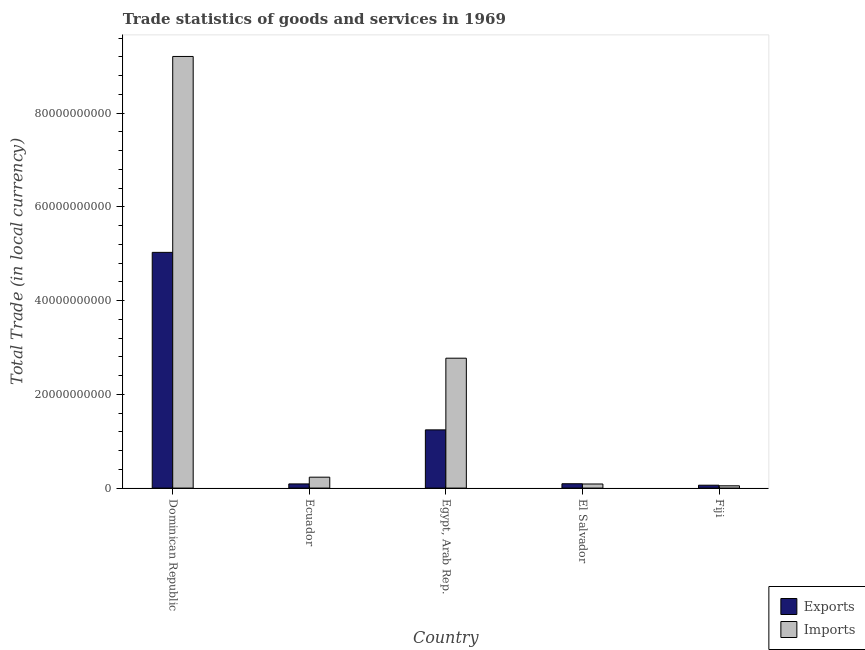How many bars are there on the 2nd tick from the left?
Provide a succinct answer. 2. How many bars are there on the 5th tick from the right?
Ensure brevity in your answer.  2. What is the label of the 1st group of bars from the left?
Make the answer very short. Dominican Republic. What is the imports of goods and services in El Salvador?
Your answer should be very brief. 8.73e+08. Across all countries, what is the maximum imports of goods and services?
Your answer should be compact. 9.21e+1. Across all countries, what is the minimum export of goods and services?
Provide a short and direct response. 6.16e+08. In which country was the imports of goods and services maximum?
Keep it short and to the point. Dominican Republic. In which country was the imports of goods and services minimum?
Make the answer very short. Fiji. What is the total imports of goods and services in the graph?
Give a very brief answer. 1.23e+11. What is the difference between the export of goods and services in Ecuador and that in Fiji?
Provide a succinct answer. 2.75e+08. What is the difference between the imports of goods and services in Ecuador and the export of goods and services in Egypt, Arab Rep.?
Your response must be concise. -1.01e+1. What is the average export of goods and services per country?
Give a very brief answer. 1.30e+1. What is the difference between the export of goods and services and imports of goods and services in Dominican Republic?
Ensure brevity in your answer.  -4.18e+1. In how many countries, is the imports of goods and services greater than 60000000000 LCU?
Your response must be concise. 1. What is the ratio of the imports of goods and services in Egypt, Arab Rep. to that in El Salvador?
Provide a short and direct response. 31.73. Is the difference between the imports of goods and services in Egypt, Arab Rep. and El Salvador greater than the difference between the export of goods and services in Egypt, Arab Rep. and El Salvador?
Keep it short and to the point. Yes. What is the difference between the highest and the second highest imports of goods and services?
Provide a short and direct response. 6.44e+1. What is the difference between the highest and the lowest export of goods and services?
Offer a terse response. 4.97e+1. In how many countries, is the export of goods and services greater than the average export of goods and services taken over all countries?
Your answer should be very brief. 1. Is the sum of the export of goods and services in Dominican Republic and El Salvador greater than the maximum imports of goods and services across all countries?
Make the answer very short. No. What does the 1st bar from the left in Fiji represents?
Your response must be concise. Exports. What does the 1st bar from the right in Fiji represents?
Make the answer very short. Imports. Are the values on the major ticks of Y-axis written in scientific E-notation?
Provide a succinct answer. No. Does the graph contain any zero values?
Ensure brevity in your answer.  No. Does the graph contain grids?
Make the answer very short. No. Where does the legend appear in the graph?
Offer a very short reply. Bottom right. How many legend labels are there?
Keep it short and to the point. 2. What is the title of the graph?
Your answer should be very brief. Trade statistics of goods and services in 1969. Does "Agricultural land" appear as one of the legend labels in the graph?
Keep it short and to the point. No. What is the label or title of the Y-axis?
Your answer should be compact. Total Trade (in local currency). What is the Total Trade (in local currency) of Exports in Dominican Republic?
Ensure brevity in your answer.  5.03e+1. What is the Total Trade (in local currency) in Imports in Dominican Republic?
Give a very brief answer. 9.21e+1. What is the Total Trade (in local currency) of Exports in Ecuador?
Provide a succinct answer. 8.91e+08. What is the Total Trade (in local currency) of Imports in Ecuador?
Your answer should be very brief. 2.33e+09. What is the Total Trade (in local currency) in Exports in Egypt, Arab Rep.?
Give a very brief answer. 1.24e+1. What is the Total Trade (in local currency) in Imports in Egypt, Arab Rep.?
Your response must be concise. 2.77e+1. What is the Total Trade (in local currency) of Exports in El Salvador?
Your answer should be very brief. 9.28e+08. What is the Total Trade (in local currency) in Imports in El Salvador?
Offer a very short reply. 8.73e+08. What is the Total Trade (in local currency) in Exports in Fiji?
Provide a succinct answer. 6.16e+08. What is the Total Trade (in local currency) in Imports in Fiji?
Give a very brief answer. 4.89e+08. Across all countries, what is the maximum Total Trade (in local currency) of Exports?
Offer a terse response. 5.03e+1. Across all countries, what is the maximum Total Trade (in local currency) of Imports?
Ensure brevity in your answer.  9.21e+1. Across all countries, what is the minimum Total Trade (in local currency) of Exports?
Your response must be concise. 6.16e+08. Across all countries, what is the minimum Total Trade (in local currency) of Imports?
Keep it short and to the point. 4.89e+08. What is the total Total Trade (in local currency) in Exports in the graph?
Provide a succinct answer. 6.51e+1. What is the total Total Trade (in local currency) of Imports in the graph?
Offer a very short reply. 1.23e+11. What is the difference between the Total Trade (in local currency) in Exports in Dominican Republic and that in Ecuador?
Give a very brief answer. 4.94e+1. What is the difference between the Total Trade (in local currency) in Imports in Dominican Republic and that in Ecuador?
Keep it short and to the point. 8.98e+1. What is the difference between the Total Trade (in local currency) in Exports in Dominican Republic and that in Egypt, Arab Rep.?
Offer a very short reply. 3.79e+1. What is the difference between the Total Trade (in local currency) in Imports in Dominican Republic and that in Egypt, Arab Rep.?
Offer a very short reply. 6.44e+1. What is the difference between the Total Trade (in local currency) in Exports in Dominican Republic and that in El Salvador?
Offer a very short reply. 4.94e+1. What is the difference between the Total Trade (in local currency) of Imports in Dominican Republic and that in El Salvador?
Provide a short and direct response. 9.12e+1. What is the difference between the Total Trade (in local currency) of Exports in Dominican Republic and that in Fiji?
Provide a succinct answer. 4.97e+1. What is the difference between the Total Trade (in local currency) in Imports in Dominican Republic and that in Fiji?
Make the answer very short. 9.16e+1. What is the difference between the Total Trade (in local currency) of Exports in Ecuador and that in Egypt, Arab Rep.?
Ensure brevity in your answer.  -1.15e+1. What is the difference between the Total Trade (in local currency) in Imports in Ecuador and that in Egypt, Arab Rep.?
Your answer should be very brief. -2.54e+1. What is the difference between the Total Trade (in local currency) of Exports in Ecuador and that in El Salvador?
Provide a succinct answer. -3.66e+07. What is the difference between the Total Trade (in local currency) in Imports in Ecuador and that in El Salvador?
Your answer should be very brief. 1.46e+09. What is the difference between the Total Trade (in local currency) of Exports in Ecuador and that in Fiji?
Make the answer very short. 2.75e+08. What is the difference between the Total Trade (in local currency) in Imports in Ecuador and that in Fiji?
Make the answer very short. 1.84e+09. What is the difference between the Total Trade (in local currency) of Exports in Egypt, Arab Rep. and that in El Salvador?
Your response must be concise. 1.15e+1. What is the difference between the Total Trade (in local currency) of Imports in Egypt, Arab Rep. and that in El Salvador?
Your answer should be compact. 2.68e+1. What is the difference between the Total Trade (in local currency) of Exports in Egypt, Arab Rep. and that in Fiji?
Offer a terse response. 1.18e+1. What is the difference between the Total Trade (in local currency) in Imports in Egypt, Arab Rep. and that in Fiji?
Keep it short and to the point. 2.72e+1. What is the difference between the Total Trade (in local currency) of Exports in El Salvador and that in Fiji?
Your answer should be very brief. 3.12e+08. What is the difference between the Total Trade (in local currency) of Imports in El Salvador and that in Fiji?
Provide a short and direct response. 3.84e+08. What is the difference between the Total Trade (in local currency) in Exports in Dominican Republic and the Total Trade (in local currency) in Imports in Ecuador?
Give a very brief answer. 4.80e+1. What is the difference between the Total Trade (in local currency) in Exports in Dominican Republic and the Total Trade (in local currency) in Imports in Egypt, Arab Rep.?
Ensure brevity in your answer.  2.26e+1. What is the difference between the Total Trade (in local currency) of Exports in Dominican Republic and the Total Trade (in local currency) of Imports in El Salvador?
Make the answer very short. 4.94e+1. What is the difference between the Total Trade (in local currency) of Exports in Dominican Republic and the Total Trade (in local currency) of Imports in Fiji?
Offer a terse response. 4.98e+1. What is the difference between the Total Trade (in local currency) in Exports in Ecuador and the Total Trade (in local currency) in Imports in Egypt, Arab Rep.?
Provide a short and direct response. -2.68e+1. What is the difference between the Total Trade (in local currency) of Exports in Ecuador and the Total Trade (in local currency) of Imports in El Salvador?
Offer a terse response. 1.78e+07. What is the difference between the Total Trade (in local currency) of Exports in Ecuador and the Total Trade (in local currency) of Imports in Fiji?
Keep it short and to the point. 4.02e+08. What is the difference between the Total Trade (in local currency) in Exports in Egypt, Arab Rep. and the Total Trade (in local currency) in Imports in El Salvador?
Offer a terse response. 1.15e+1. What is the difference between the Total Trade (in local currency) of Exports in Egypt, Arab Rep. and the Total Trade (in local currency) of Imports in Fiji?
Keep it short and to the point. 1.19e+1. What is the difference between the Total Trade (in local currency) of Exports in El Salvador and the Total Trade (in local currency) of Imports in Fiji?
Ensure brevity in your answer.  4.39e+08. What is the average Total Trade (in local currency) in Exports per country?
Your answer should be very brief. 1.30e+1. What is the average Total Trade (in local currency) of Imports per country?
Your answer should be very brief. 2.47e+1. What is the difference between the Total Trade (in local currency) of Exports and Total Trade (in local currency) of Imports in Dominican Republic?
Your response must be concise. -4.18e+1. What is the difference between the Total Trade (in local currency) in Exports and Total Trade (in local currency) in Imports in Ecuador?
Offer a very short reply. -1.44e+09. What is the difference between the Total Trade (in local currency) in Exports and Total Trade (in local currency) in Imports in Egypt, Arab Rep.?
Provide a succinct answer. -1.53e+1. What is the difference between the Total Trade (in local currency) in Exports and Total Trade (in local currency) in Imports in El Salvador?
Keep it short and to the point. 5.44e+07. What is the difference between the Total Trade (in local currency) in Exports and Total Trade (in local currency) in Imports in Fiji?
Provide a short and direct response. 1.27e+08. What is the ratio of the Total Trade (in local currency) of Exports in Dominican Republic to that in Ecuador?
Provide a succinct answer. 56.43. What is the ratio of the Total Trade (in local currency) in Imports in Dominican Republic to that in Ecuador?
Ensure brevity in your answer.  39.55. What is the ratio of the Total Trade (in local currency) of Exports in Dominican Republic to that in Egypt, Arab Rep.?
Your answer should be compact. 4.05. What is the ratio of the Total Trade (in local currency) of Imports in Dominican Republic to that in Egypt, Arab Rep.?
Ensure brevity in your answer.  3.32. What is the ratio of the Total Trade (in local currency) of Exports in Dominican Republic to that in El Salvador?
Offer a very short reply. 54.2. What is the ratio of the Total Trade (in local currency) in Imports in Dominican Republic to that in El Salvador?
Ensure brevity in your answer.  105.44. What is the ratio of the Total Trade (in local currency) of Exports in Dominican Republic to that in Fiji?
Your answer should be compact. 81.63. What is the ratio of the Total Trade (in local currency) of Imports in Dominican Republic to that in Fiji?
Your answer should be very brief. 188.21. What is the ratio of the Total Trade (in local currency) in Exports in Ecuador to that in Egypt, Arab Rep.?
Offer a very short reply. 0.07. What is the ratio of the Total Trade (in local currency) in Imports in Ecuador to that in Egypt, Arab Rep.?
Your answer should be very brief. 0.08. What is the ratio of the Total Trade (in local currency) in Exports in Ecuador to that in El Salvador?
Provide a short and direct response. 0.96. What is the ratio of the Total Trade (in local currency) in Imports in Ecuador to that in El Salvador?
Ensure brevity in your answer.  2.67. What is the ratio of the Total Trade (in local currency) of Exports in Ecuador to that in Fiji?
Offer a terse response. 1.45. What is the ratio of the Total Trade (in local currency) of Imports in Ecuador to that in Fiji?
Your response must be concise. 4.76. What is the ratio of the Total Trade (in local currency) of Exports in Egypt, Arab Rep. to that in El Salvador?
Ensure brevity in your answer.  13.39. What is the ratio of the Total Trade (in local currency) of Imports in Egypt, Arab Rep. to that in El Salvador?
Your answer should be compact. 31.73. What is the ratio of the Total Trade (in local currency) in Exports in Egypt, Arab Rep. to that in Fiji?
Ensure brevity in your answer.  20.16. What is the ratio of the Total Trade (in local currency) in Imports in Egypt, Arab Rep. to that in Fiji?
Ensure brevity in your answer.  56.64. What is the ratio of the Total Trade (in local currency) in Exports in El Salvador to that in Fiji?
Make the answer very short. 1.51. What is the ratio of the Total Trade (in local currency) in Imports in El Salvador to that in Fiji?
Your answer should be very brief. 1.79. What is the difference between the highest and the second highest Total Trade (in local currency) in Exports?
Offer a terse response. 3.79e+1. What is the difference between the highest and the second highest Total Trade (in local currency) of Imports?
Your response must be concise. 6.44e+1. What is the difference between the highest and the lowest Total Trade (in local currency) of Exports?
Offer a very short reply. 4.97e+1. What is the difference between the highest and the lowest Total Trade (in local currency) in Imports?
Provide a short and direct response. 9.16e+1. 